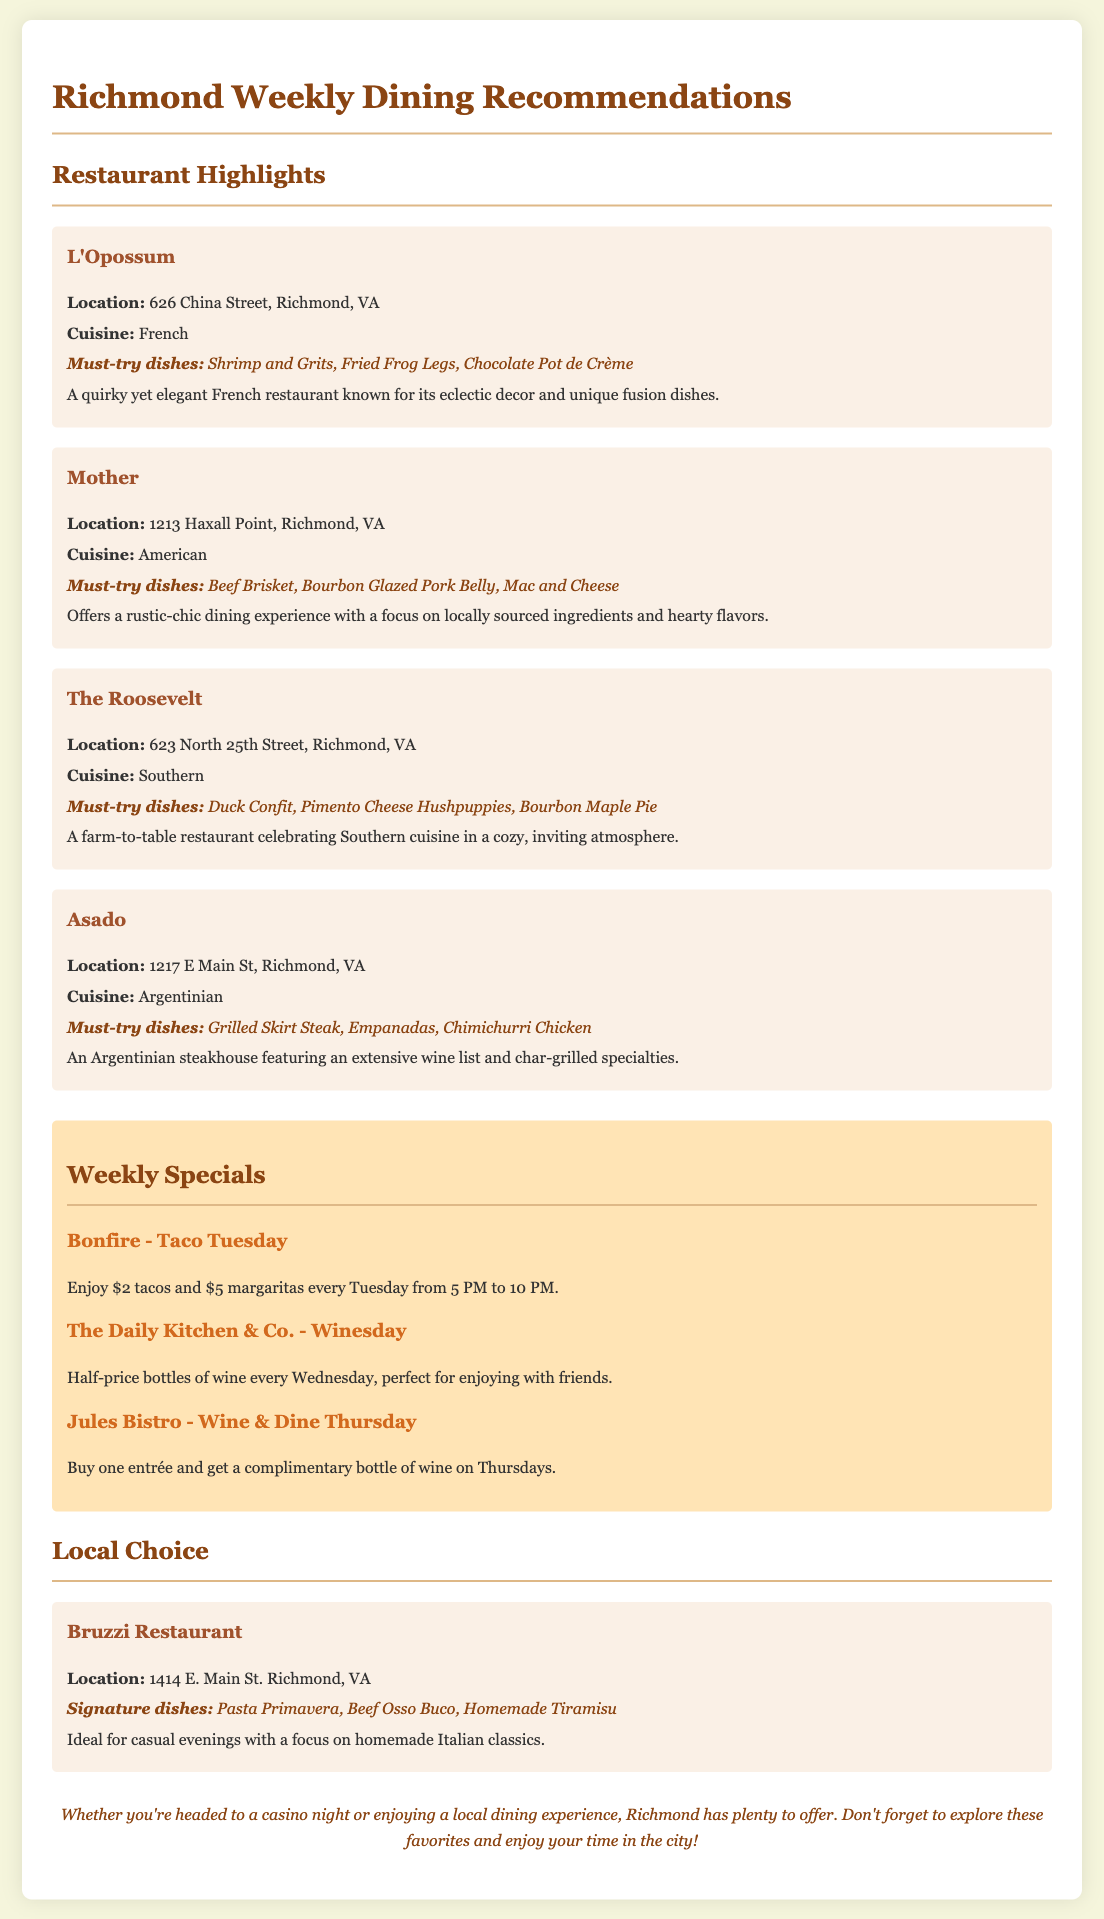What is the location of L'Opossum? L'Opossum is located at 626 China Street, Richmond, VA.
Answer: 626 China Street, Richmond, VA What type of cuisine does Mother serve? Mother serves American cuisine as indicated in the document.
Answer: American What is the must-try dish at The Roosevelt? The document lists Duck Confit as a must-try dish at The Roosevelt.
Answer: Duck Confit What is the special offer at Bonfire on Taco Tuesdays? The special offer includes $2 tacos and $5 margaritas every Tuesday from 5 PM to 10 PM.
Answer: $2 tacos and $5 margaritas How many must-try dishes are listed for Asado? The document states three must-try dishes for Asado.
Answer: Three Which restaurant has a focus on homemade Italian classics? The document mentions Bruzzi Restaurant as focusing on homemade Italian classics.
Answer: Bruzzi Restaurant On which day is half-price bottles of wine available? The Daily Kitchen & Co. offers half-price bottles of wine on Wednesdays.
Answer: Wednesdays What is the signature dish at Bruzzi Restaurant? The signature dishes include Pasta Primavera as listed in the document.
Answer: Pasta Primavera What cuisine is served at Asado? Asado offers Argentinian cuisine according to the information provided.
Answer: Argentinian 